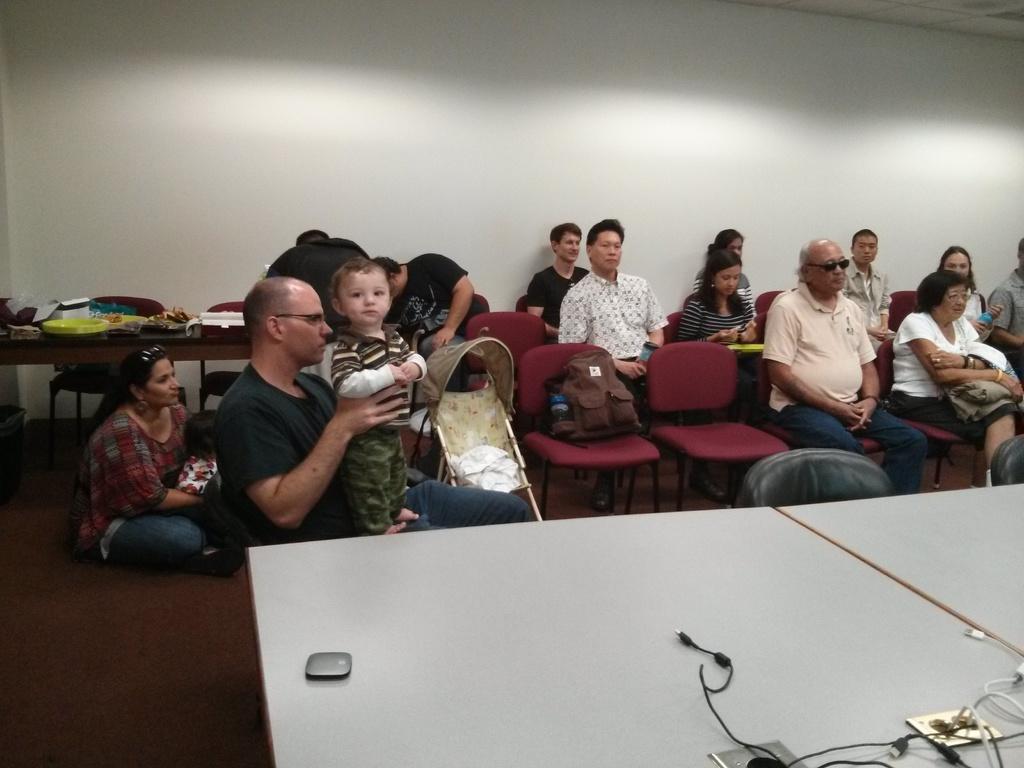Could you give a brief overview of what you see in this image? In this image there are group of people sitting on a chair. Woman at the left side is sitting on the floor holding a boy in her hand. In the center man is holding a boy who is standing on his lap. In the front there is a table on the table there are two wires. In the background there are men sitting on the chairs. 